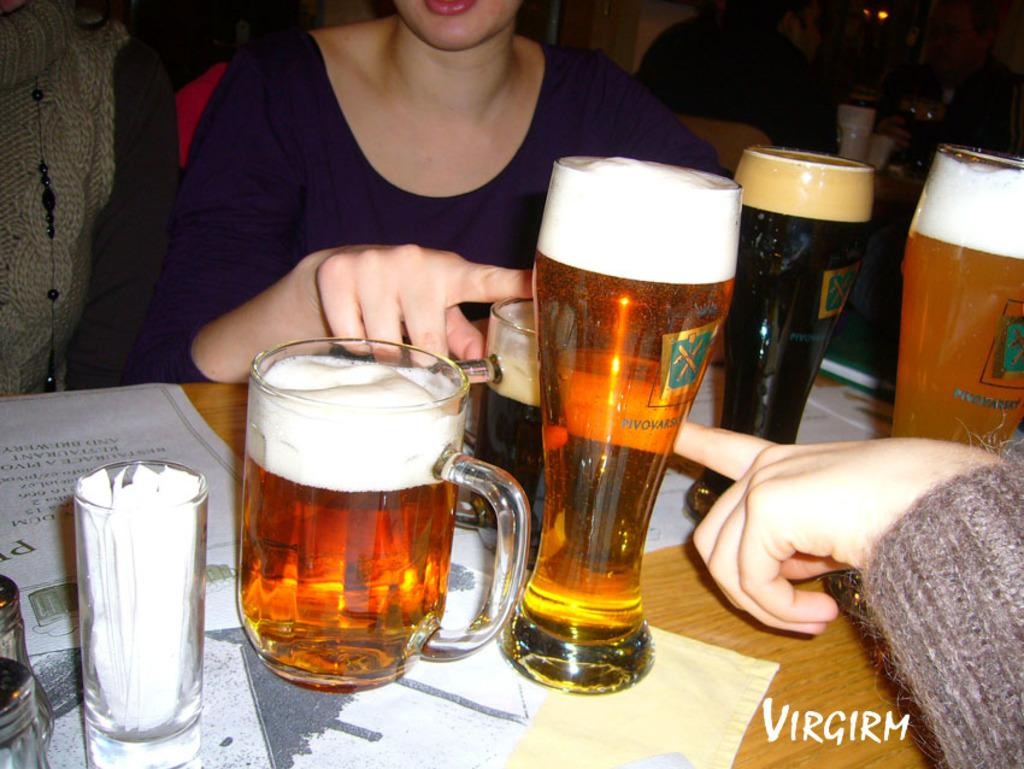What is the main piece of furniture in the image? There is there a table in the image? What objects are on the table? There are beer glasses and papers on the table. What are the people in the image doing? People are sitting on chairs around the table. Is there any text in the image? Yes, there is some text in the bottom right corner of the image. Is there a veil covering the beer glasses in the image? No, there is no veil present in the image, and the beer glasses are not covered. What time of day is it in the image, given that it's morning? The time of day is not mentioned or indicated in the image, so we cannot determine if it's morning or not. 